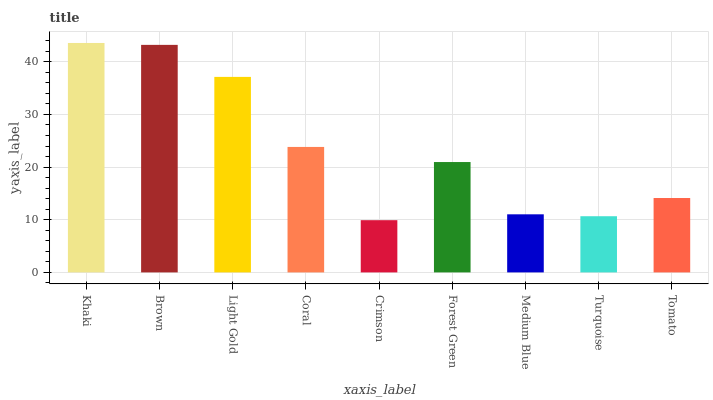Is Crimson the minimum?
Answer yes or no. Yes. Is Khaki the maximum?
Answer yes or no. Yes. Is Brown the minimum?
Answer yes or no. No. Is Brown the maximum?
Answer yes or no. No. Is Khaki greater than Brown?
Answer yes or no. Yes. Is Brown less than Khaki?
Answer yes or no. Yes. Is Brown greater than Khaki?
Answer yes or no. No. Is Khaki less than Brown?
Answer yes or no. No. Is Forest Green the high median?
Answer yes or no. Yes. Is Forest Green the low median?
Answer yes or no. Yes. Is Crimson the high median?
Answer yes or no. No. Is Brown the low median?
Answer yes or no. No. 